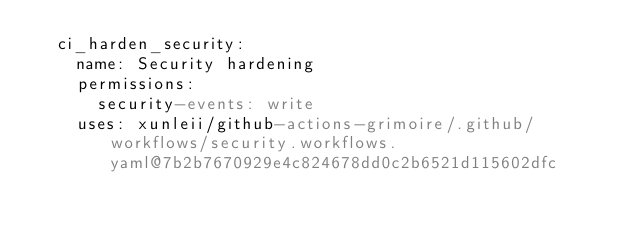<code> <loc_0><loc_0><loc_500><loc_500><_YAML_>  ci_harden_security:
    name: Security hardening
    permissions:
      security-events: write
    uses: xunleii/github-actions-grimoire/.github/workflows/security.workflows.yaml@7b2b7670929e4c824678dd0c2b6521d115602dfc
</code> 